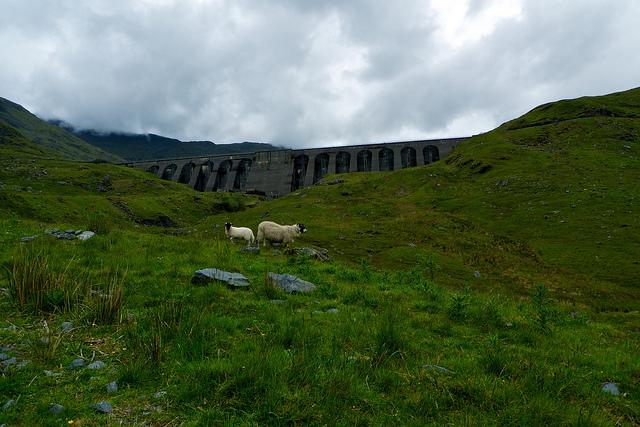People live here?
Write a very short answer. No. Are the animals walking downhill?
Keep it brief. Yes. What is the weather like?
Quick response, please. Cloudy. Are the two sheep facing each other?
Give a very brief answer. No. What type of land is pictured?
Quick response, please. Pasture. How many sheep are presented?
Concise answer only. 2. How is the plantation?
Give a very brief answer. Green. 